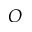Convert formula to latex. <formula><loc_0><loc_0><loc_500><loc_500>O</formula> 